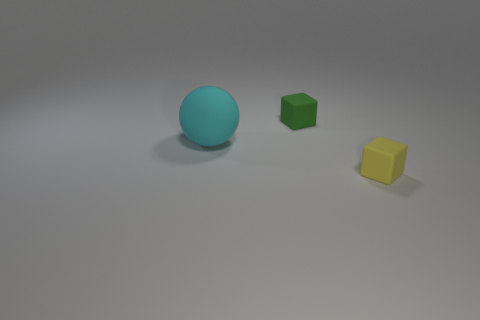Are there any other things that have the same size as the cyan matte ball?
Provide a short and direct response. No. What number of things are either big cyan balls or tiny yellow rubber blocks?
Provide a short and direct response. 2. There is a cube to the right of the green matte block; is it the same size as the green object?
Your answer should be very brief. Yes. What number of other objects are there of the same size as the green matte cube?
Your response must be concise. 1. Are any yellow metal cubes visible?
Give a very brief answer. No. What is the size of the rubber thing on the left side of the small block behind the tiny yellow rubber thing?
Offer a terse response. Large. There is a small rubber thing that is on the right side of the green cube; is its color the same as the small rubber block behind the yellow rubber object?
Make the answer very short. No. The matte thing that is both right of the large cyan sphere and behind the yellow matte cube is what color?
Your response must be concise. Green. How many other objects are the same shape as the small green object?
Your response must be concise. 1. What is the color of the other matte block that is the same size as the yellow rubber block?
Give a very brief answer. Green. 